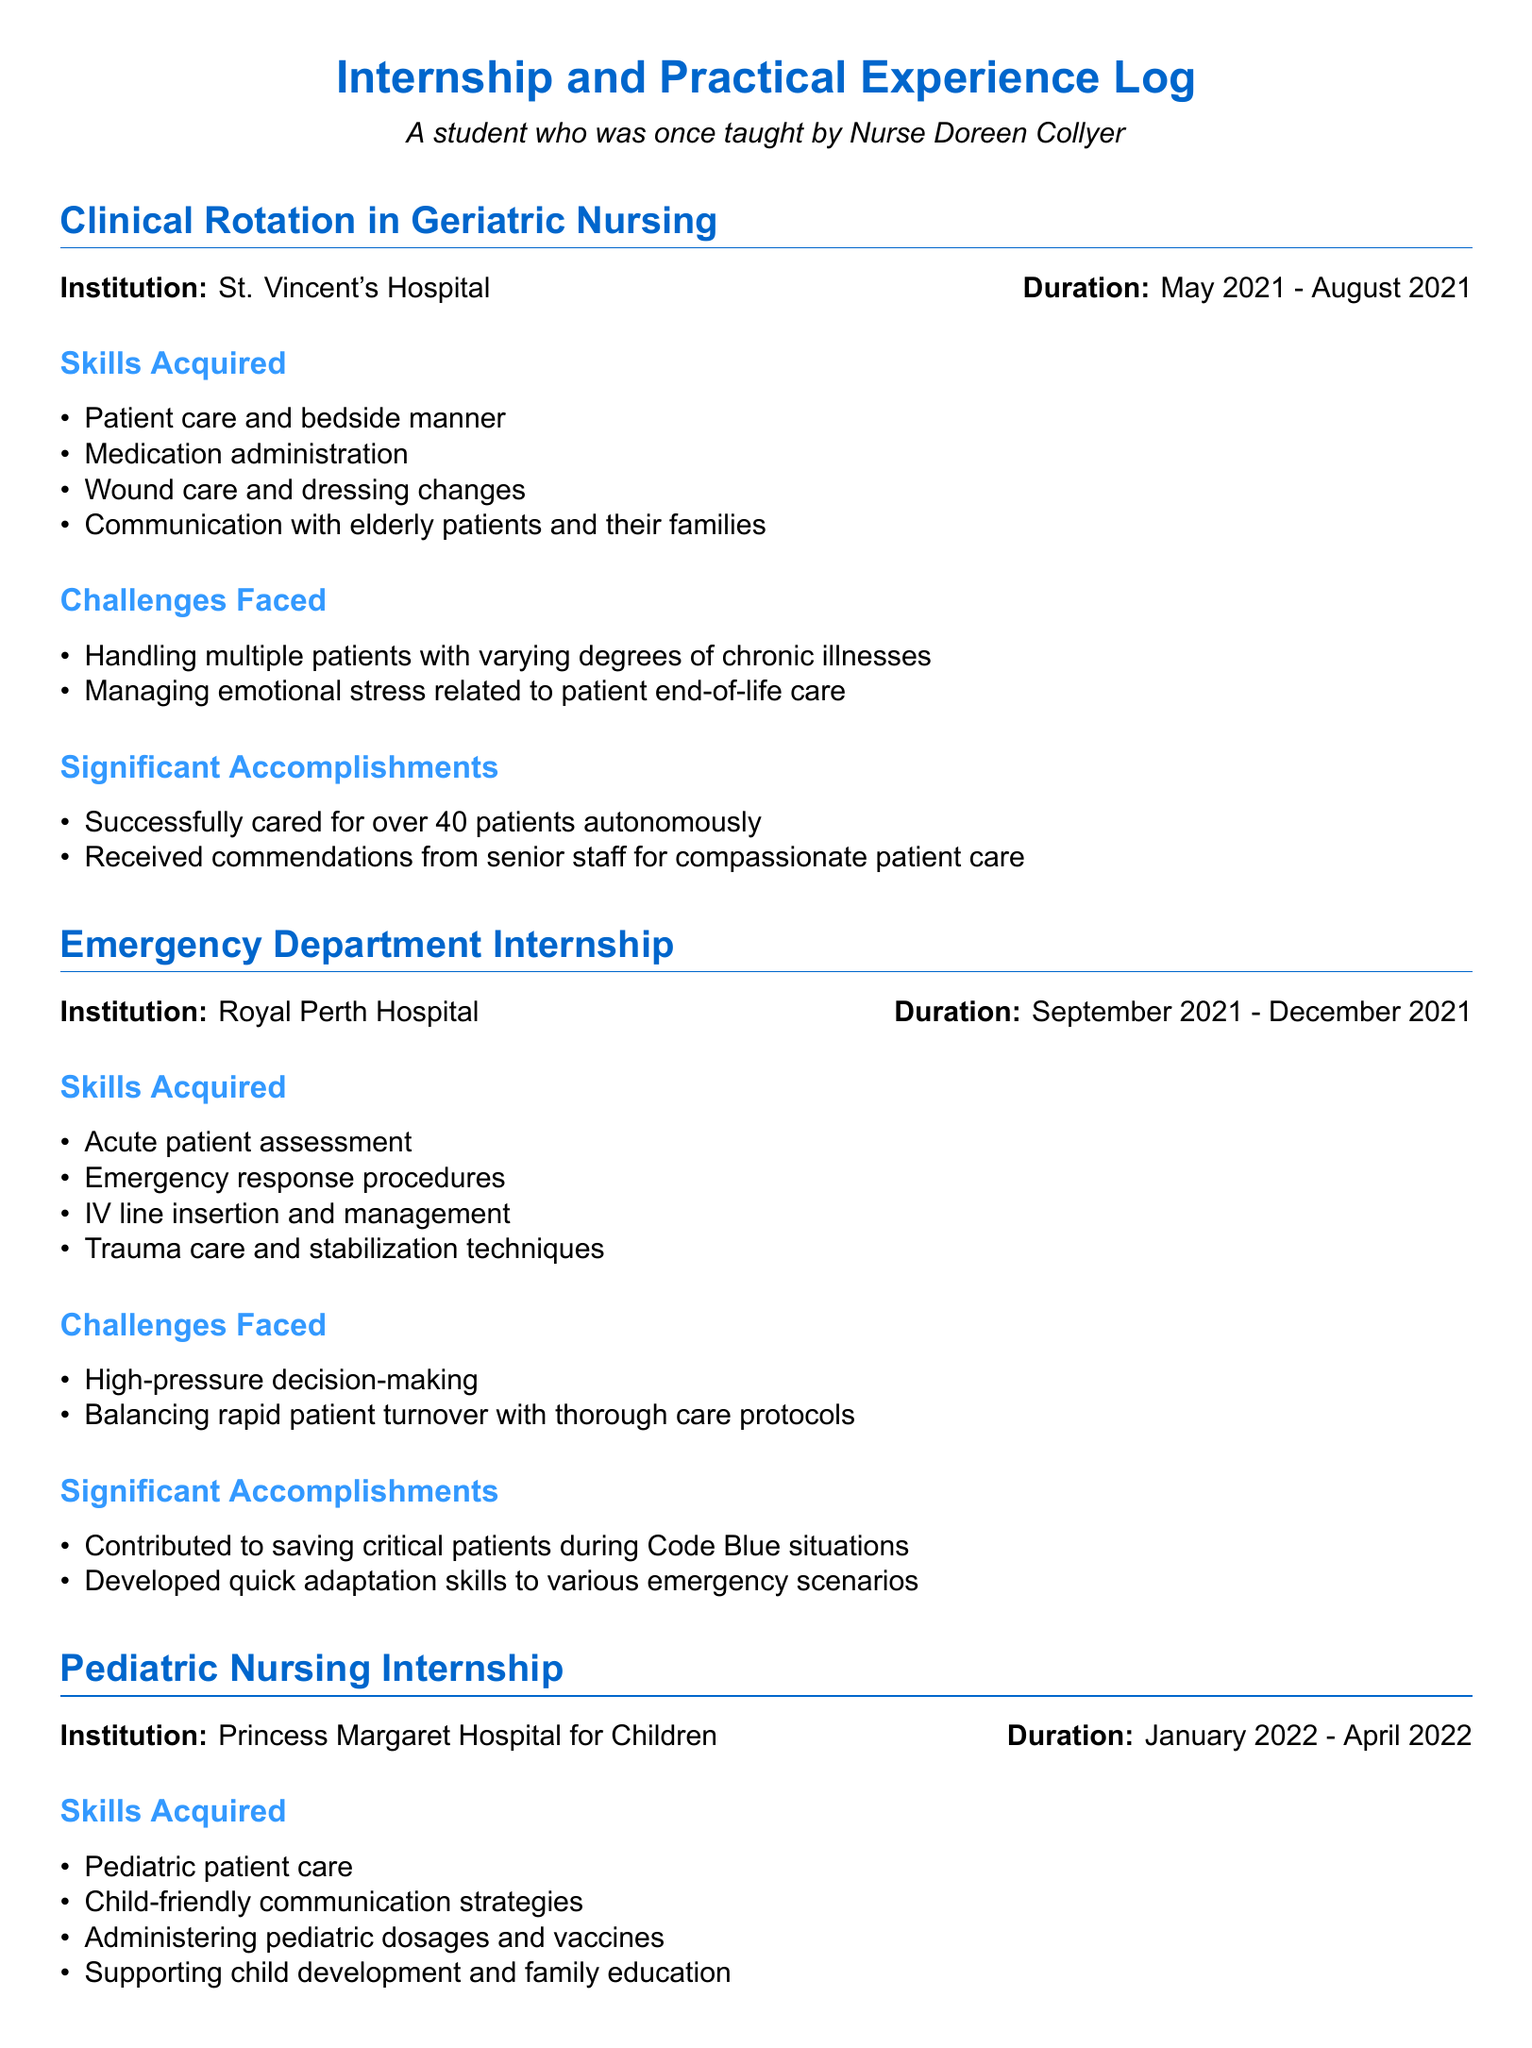what was the duration of the Clinical Rotation in Geriatric Nursing? The duration is specified as May 2021 to August 2021.
Answer: May 2021 - August 2021 what skills were acquired during the Emergency Department Internship? The skills are listed in a bullet point format, including acute patient assessment and emergency response procedures.
Answer: Acute patient assessment, emergency response procedures, IV line insertion and management, trauma care and stabilization techniques what significant accomplishment is highlighted in the Pediatric Nursing Internship? The significant accomplishments are noted to include building rapport with pediatric patients and creating educational materials.
Answer: Built strong rapport with pediatric patients and their families what challenges were faced during the Community Health Nursing Placement? The document mentions challenges such as addressing healthcare disparities and managing large caseloads.
Answer: Addressing healthcare disparities in underserved populations, managing large caseloads with limited resources how many patients were cared for autonomously during the Geriatric Nursing rotation? This information is found in the accomplishments section, noting the number cared for.
Answer: Over 40 patients autonomously 